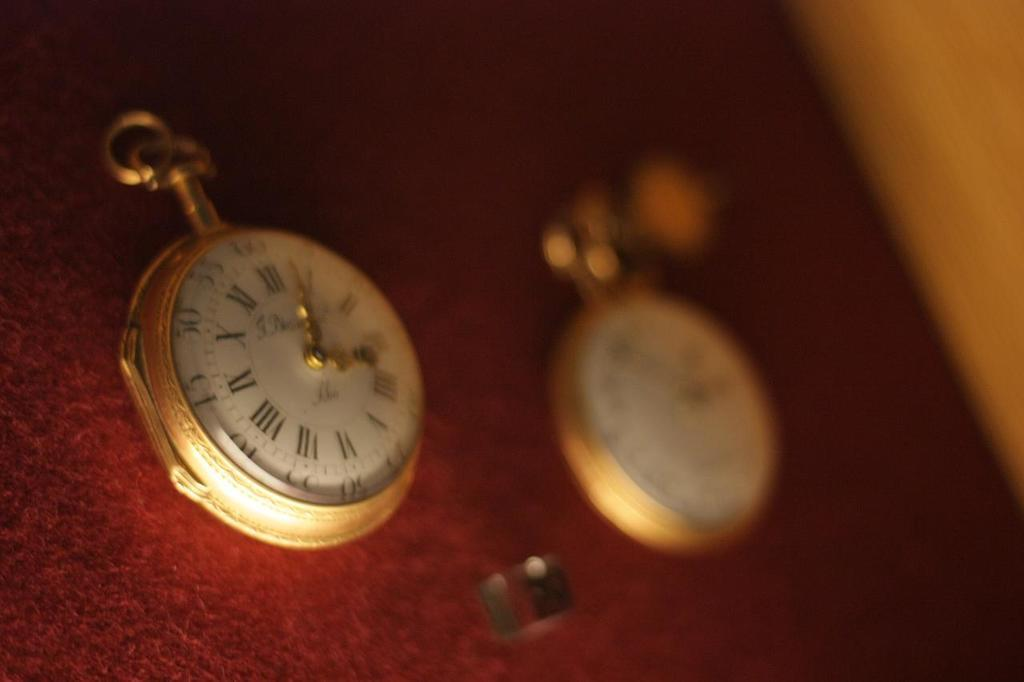<image>
Offer a succinct explanation of the picture presented. Face of a watch with the hands on the numbers 12 and 3. 